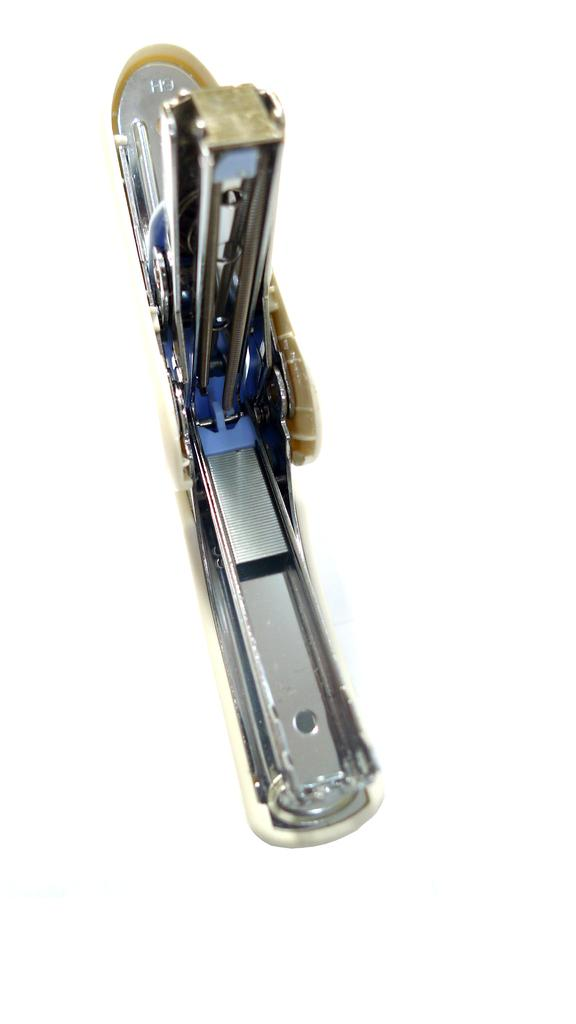What object can be seen in the image? There is a stapler in the image. What color is the background of the image? The background of the image is white. What type of drum is being played by the son in the image? There is no son or drum present in the image; it only features a stapler against a white background. 